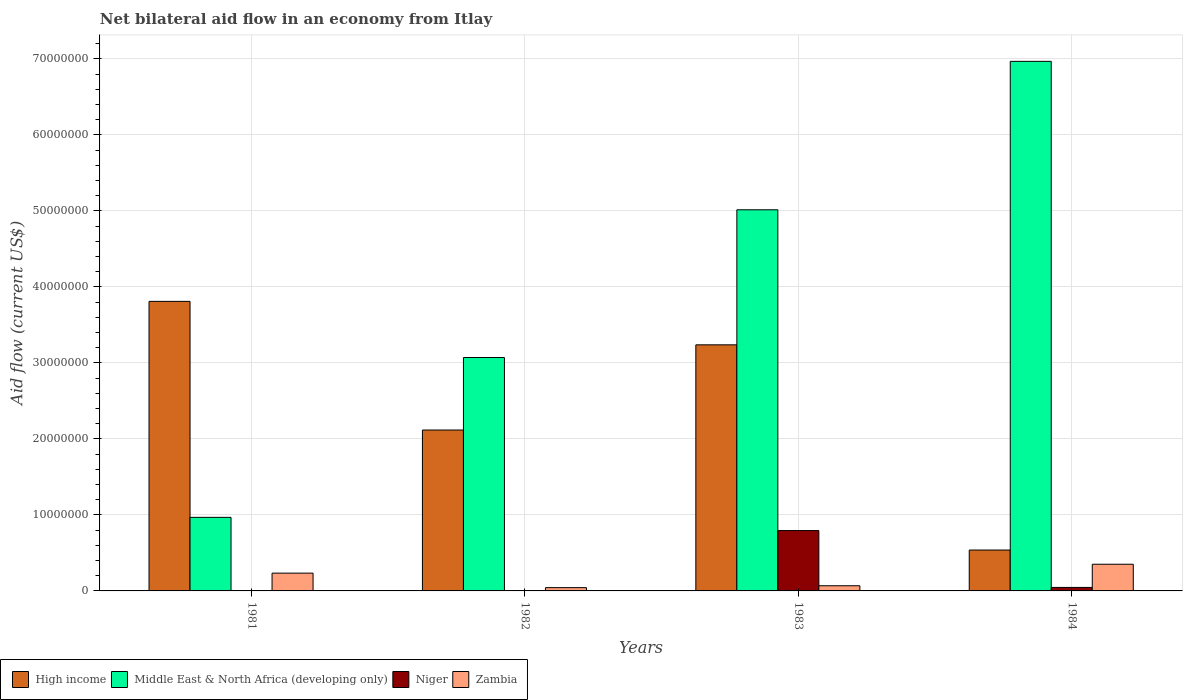How many groups of bars are there?
Offer a very short reply. 4. Are the number of bars per tick equal to the number of legend labels?
Provide a succinct answer. Yes. What is the label of the 3rd group of bars from the left?
Offer a terse response. 1983. In how many cases, is the number of bars for a given year not equal to the number of legend labels?
Offer a very short reply. 0. What is the net bilateral aid flow in Zambia in 1981?
Your answer should be compact. 2.34e+06. Across all years, what is the maximum net bilateral aid flow in Middle East & North Africa (developing only)?
Give a very brief answer. 6.97e+07. What is the total net bilateral aid flow in Middle East & North Africa (developing only) in the graph?
Your response must be concise. 1.60e+08. What is the difference between the net bilateral aid flow in Middle East & North Africa (developing only) in 1983 and that in 1984?
Make the answer very short. -1.95e+07. What is the difference between the net bilateral aid flow in Zambia in 1983 and the net bilateral aid flow in High income in 1984?
Your response must be concise. -4.70e+06. What is the average net bilateral aid flow in High income per year?
Make the answer very short. 2.43e+07. In the year 1981, what is the difference between the net bilateral aid flow in Zambia and net bilateral aid flow in High income?
Provide a succinct answer. -3.58e+07. In how many years, is the net bilateral aid flow in High income greater than 18000000 US$?
Make the answer very short. 3. What is the ratio of the net bilateral aid flow in Zambia in 1981 to that in 1984?
Your answer should be compact. 0.67. Is the net bilateral aid flow in Niger in 1981 less than that in 1982?
Your response must be concise. No. Is the difference between the net bilateral aid flow in Zambia in 1981 and 1984 greater than the difference between the net bilateral aid flow in High income in 1981 and 1984?
Give a very brief answer. No. What is the difference between the highest and the second highest net bilateral aid flow in Middle East & North Africa (developing only)?
Offer a terse response. 1.95e+07. What is the difference between the highest and the lowest net bilateral aid flow in Niger?
Offer a terse response. 7.92e+06. Is it the case that in every year, the sum of the net bilateral aid flow in Middle East & North Africa (developing only) and net bilateral aid flow in Zambia is greater than the sum of net bilateral aid flow in High income and net bilateral aid flow in Niger?
Provide a succinct answer. No. What does the 2nd bar from the left in 1984 represents?
Your answer should be very brief. Middle East & North Africa (developing only). What does the 2nd bar from the right in 1981 represents?
Give a very brief answer. Niger. Are all the bars in the graph horizontal?
Offer a very short reply. No. Does the graph contain any zero values?
Ensure brevity in your answer.  No. Where does the legend appear in the graph?
Provide a short and direct response. Bottom left. What is the title of the graph?
Make the answer very short. Net bilateral aid flow in an economy from Itlay. Does "Jamaica" appear as one of the legend labels in the graph?
Ensure brevity in your answer.  No. What is the label or title of the X-axis?
Keep it short and to the point. Years. What is the label or title of the Y-axis?
Make the answer very short. Aid flow (current US$). What is the Aid flow (current US$) of High income in 1981?
Offer a terse response. 3.81e+07. What is the Aid flow (current US$) of Middle East & North Africa (developing only) in 1981?
Make the answer very short. 9.68e+06. What is the Aid flow (current US$) in Niger in 1981?
Your response must be concise. 4.00e+04. What is the Aid flow (current US$) in Zambia in 1981?
Offer a very short reply. 2.34e+06. What is the Aid flow (current US$) of High income in 1982?
Give a very brief answer. 2.12e+07. What is the Aid flow (current US$) of Middle East & North Africa (developing only) in 1982?
Offer a terse response. 3.07e+07. What is the Aid flow (current US$) in Zambia in 1982?
Ensure brevity in your answer.  4.30e+05. What is the Aid flow (current US$) of High income in 1983?
Provide a succinct answer. 3.24e+07. What is the Aid flow (current US$) in Middle East & North Africa (developing only) in 1983?
Keep it short and to the point. 5.02e+07. What is the Aid flow (current US$) in Niger in 1983?
Your answer should be very brief. 7.94e+06. What is the Aid flow (current US$) of Zambia in 1983?
Your response must be concise. 6.80e+05. What is the Aid flow (current US$) in High income in 1984?
Keep it short and to the point. 5.38e+06. What is the Aid flow (current US$) of Middle East & North Africa (developing only) in 1984?
Provide a short and direct response. 6.97e+07. What is the Aid flow (current US$) in Zambia in 1984?
Your response must be concise. 3.51e+06. Across all years, what is the maximum Aid flow (current US$) of High income?
Give a very brief answer. 3.81e+07. Across all years, what is the maximum Aid flow (current US$) of Middle East & North Africa (developing only)?
Your response must be concise. 6.97e+07. Across all years, what is the maximum Aid flow (current US$) of Niger?
Offer a terse response. 7.94e+06. Across all years, what is the maximum Aid flow (current US$) in Zambia?
Your response must be concise. 3.51e+06. Across all years, what is the minimum Aid flow (current US$) of High income?
Offer a very short reply. 5.38e+06. Across all years, what is the minimum Aid flow (current US$) in Middle East & North Africa (developing only)?
Offer a very short reply. 9.68e+06. Across all years, what is the minimum Aid flow (current US$) in Niger?
Your answer should be very brief. 2.00e+04. What is the total Aid flow (current US$) in High income in the graph?
Give a very brief answer. 9.70e+07. What is the total Aid flow (current US$) of Middle East & North Africa (developing only) in the graph?
Your answer should be compact. 1.60e+08. What is the total Aid flow (current US$) in Niger in the graph?
Keep it short and to the point. 8.46e+06. What is the total Aid flow (current US$) of Zambia in the graph?
Give a very brief answer. 6.96e+06. What is the difference between the Aid flow (current US$) in High income in 1981 and that in 1982?
Your answer should be compact. 1.69e+07. What is the difference between the Aid flow (current US$) in Middle East & North Africa (developing only) in 1981 and that in 1982?
Make the answer very short. -2.10e+07. What is the difference between the Aid flow (current US$) in Niger in 1981 and that in 1982?
Your response must be concise. 2.00e+04. What is the difference between the Aid flow (current US$) of Zambia in 1981 and that in 1982?
Your answer should be compact. 1.91e+06. What is the difference between the Aid flow (current US$) of High income in 1981 and that in 1983?
Keep it short and to the point. 5.72e+06. What is the difference between the Aid flow (current US$) of Middle East & North Africa (developing only) in 1981 and that in 1983?
Give a very brief answer. -4.05e+07. What is the difference between the Aid flow (current US$) in Niger in 1981 and that in 1983?
Your response must be concise. -7.90e+06. What is the difference between the Aid flow (current US$) in Zambia in 1981 and that in 1983?
Keep it short and to the point. 1.66e+06. What is the difference between the Aid flow (current US$) in High income in 1981 and that in 1984?
Offer a terse response. 3.27e+07. What is the difference between the Aid flow (current US$) in Middle East & North Africa (developing only) in 1981 and that in 1984?
Provide a succinct answer. -6.00e+07. What is the difference between the Aid flow (current US$) of Niger in 1981 and that in 1984?
Your answer should be very brief. -4.20e+05. What is the difference between the Aid flow (current US$) in Zambia in 1981 and that in 1984?
Provide a short and direct response. -1.17e+06. What is the difference between the Aid flow (current US$) of High income in 1982 and that in 1983?
Provide a succinct answer. -1.12e+07. What is the difference between the Aid flow (current US$) of Middle East & North Africa (developing only) in 1982 and that in 1983?
Ensure brevity in your answer.  -1.94e+07. What is the difference between the Aid flow (current US$) of Niger in 1982 and that in 1983?
Offer a very short reply. -7.92e+06. What is the difference between the Aid flow (current US$) in High income in 1982 and that in 1984?
Make the answer very short. 1.58e+07. What is the difference between the Aid flow (current US$) of Middle East & North Africa (developing only) in 1982 and that in 1984?
Give a very brief answer. -3.90e+07. What is the difference between the Aid flow (current US$) of Niger in 1982 and that in 1984?
Your answer should be very brief. -4.40e+05. What is the difference between the Aid flow (current US$) of Zambia in 1982 and that in 1984?
Offer a very short reply. -3.08e+06. What is the difference between the Aid flow (current US$) in High income in 1983 and that in 1984?
Provide a succinct answer. 2.70e+07. What is the difference between the Aid flow (current US$) of Middle East & North Africa (developing only) in 1983 and that in 1984?
Keep it short and to the point. -1.95e+07. What is the difference between the Aid flow (current US$) of Niger in 1983 and that in 1984?
Offer a terse response. 7.48e+06. What is the difference between the Aid flow (current US$) of Zambia in 1983 and that in 1984?
Make the answer very short. -2.83e+06. What is the difference between the Aid flow (current US$) in High income in 1981 and the Aid flow (current US$) in Middle East & North Africa (developing only) in 1982?
Keep it short and to the point. 7.39e+06. What is the difference between the Aid flow (current US$) of High income in 1981 and the Aid flow (current US$) of Niger in 1982?
Offer a terse response. 3.81e+07. What is the difference between the Aid flow (current US$) of High income in 1981 and the Aid flow (current US$) of Zambia in 1982?
Offer a very short reply. 3.77e+07. What is the difference between the Aid flow (current US$) in Middle East & North Africa (developing only) in 1981 and the Aid flow (current US$) in Niger in 1982?
Provide a succinct answer. 9.66e+06. What is the difference between the Aid flow (current US$) in Middle East & North Africa (developing only) in 1981 and the Aid flow (current US$) in Zambia in 1982?
Ensure brevity in your answer.  9.25e+06. What is the difference between the Aid flow (current US$) in Niger in 1981 and the Aid flow (current US$) in Zambia in 1982?
Give a very brief answer. -3.90e+05. What is the difference between the Aid flow (current US$) of High income in 1981 and the Aid flow (current US$) of Middle East & North Africa (developing only) in 1983?
Your answer should be very brief. -1.20e+07. What is the difference between the Aid flow (current US$) in High income in 1981 and the Aid flow (current US$) in Niger in 1983?
Your answer should be very brief. 3.02e+07. What is the difference between the Aid flow (current US$) in High income in 1981 and the Aid flow (current US$) in Zambia in 1983?
Give a very brief answer. 3.74e+07. What is the difference between the Aid flow (current US$) in Middle East & North Africa (developing only) in 1981 and the Aid flow (current US$) in Niger in 1983?
Keep it short and to the point. 1.74e+06. What is the difference between the Aid flow (current US$) in Middle East & North Africa (developing only) in 1981 and the Aid flow (current US$) in Zambia in 1983?
Offer a very short reply. 9.00e+06. What is the difference between the Aid flow (current US$) of Niger in 1981 and the Aid flow (current US$) of Zambia in 1983?
Ensure brevity in your answer.  -6.40e+05. What is the difference between the Aid flow (current US$) in High income in 1981 and the Aid flow (current US$) in Middle East & North Africa (developing only) in 1984?
Your answer should be compact. -3.16e+07. What is the difference between the Aid flow (current US$) in High income in 1981 and the Aid flow (current US$) in Niger in 1984?
Your answer should be compact. 3.76e+07. What is the difference between the Aid flow (current US$) in High income in 1981 and the Aid flow (current US$) in Zambia in 1984?
Offer a very short reply. 3.46e+07. What is the difference between the Aid flow (current US$) in Middle East & North Africa (developing only) in 1981 and the Aid flow (current US$) in Niger in 1984?
Your response must be concise. 9.22e+06. What is the difference between the Aid flow (current US$) in Middle East & North Africa (developing only) in 1981 and the Aid flow (current US$) in Zambia in 1984?
Your response must be concise. 6.17e+06. What is the difference between the Aid flow (current US$) in Niger in 1981 and the Aid flow (current US$) in Zambia in 1984?
Ensure brevity in your answer.  -3.47e+06. What is the difference between the Aid flow (current US$) of High income in 1982 and the Aid flow (current US$) of Middle East & North Africa (developing only) in 1983?
Ensure brevity in your answer.  -2.90e+07. What is the difference between the Aid flow (current US$) in High income in 1982 and the Aid flow (current US$) in Niger in 1983?
Provide a succinct answer. 1.32e+07. What is the difference between the Aid flow (current US$) of High income in 1982 and the Aid flow (current US$) of Zambia in 1983?
Offer a very short reply. 2.05e+07. What is the difference between the Aid flow (current US$) in Middle East & North Africa (developing only) in 1982 and the Aid flow (current US$) in Niger in 1983?
Your answer should be compact. 2.28e+07. What is the difference between the Aid flow (current US$) in Middle East & North Africa (developing only) in 1982 and the Aid flow (current US$) in Zambia in 1983?
Give a very brief answer. 3.00e+07. What is the difference between the Aid flow (current US$) in Niger in 1982 and the Aid flow (current US$) in Zambia in 1983?
Your response must be concise. -6.60e+05. What is the difference between the Aid flow (current US$) of High income in 1982 and the Aid flow (current US$) of Middle East & North Africa (developing only) in 1984?
Provide a succinct answer. -4.85e+07. What is the difference between the Aid flow (current US$) of High income in 1982 and the Aid flow (current US$) of Niger in 1984?
Offer a terse response. 2.07e+07. What is the difference between the Aid flow (current US$) in High income in 1982 and the Aid flow (current US$) in Zambia in 1984?
Make the answer very short. 1.77e+07. What is the difference between the Aid flow (current US$) in Middle East & North Africa (developing only) in 1982 and the Aid flow (current US$) in Niger in 1984?
Offer a terse response. 3.02e+07. What is the difference between the Aid flow (current US$) in Middle East & North Africa (developing only) in 1982 and the Aid flow (current US$) in Zambia in 1984?
Your answer should be compact. 2.72e+07. What is the difference between the Aid flow (current US$) in Niger in 1982 and the Aid flow (current US$) in Zambia in 1984?
Make the answer very short. -3.49e+06. What is the difference between the Aid flow (current US$) in High income in 1983 and the Aid flow (current US$) in Middle East & North Africa (developing only) in 1984?
Offer a very short reply. -3.73e+07. What is the difference between the Aid flow (current US$) of High income in 1983 and the Aid flow (current US$) of Niger in 1984?
Make the answer very short. 3.19e+07. What is the difference between the Aid flow (current US$) of High income in 1983 and the Aid flow (current US$) of Zambia in 1984?
Offer a terse response. 2.89e+07. What is the difference between the Aid flow (current US$) in Middle East & North Africa (developing only) in 1983 and the Aid flow (current US$) in Niger in 1984?
Ensure brevity in your answer.  4.97e+07. What is the difference between the Aid flow (current US$) in Middle East & North Africa (developing only) in 1983 and the Aid flow (current US$) in Zambia in 1984?
Provide a succinct answer. 4.66e+07. What is the difference between the Aid flow (current US$) of Niger in 1983 and the Aid flow (current US$) of Zambia in 1984?
Your response must be concise. 4.43e+06. What is the average Aid flow (current US$) of High income per year?
Your answer should be very brief. 2.43e+07. What is the average Aid flow (current US$) in Middle East & North Africa (developing only) per year?
Make the answer very short. 4.01e+07. What is the average Aid flow (current US$) of Niger per year?
Keep it short and to the point. 2.12e+06. What is the average Aid flow (current US$) in Zambia per year?
Your response must be concise. 1.74e+06. In the year 1981, what is the difference between the Aid flow (current US$) in High income and Aid flow (current US$) in Middle East & North Africa (developing only)?
Give a very brief answer. 2.84e+07. In the year 1981, what is the difference between the Aid flow (current US$) of High income and Aid flow (current US$) of Niger?
Ensure brevity in your answer.  3.81e+07. In the year 1981, what is the difference between the Aid flow (current US$) of High income and Aid flow (current US$) of Zambia?
Provide a succinct answer. 3.58e+07. In the year 1981, what is the difference between the Aid flow (current US$) in Middle East & North Africa (developing only) and Aid flow (current US$) in Niger?
Offer a terse response. 9.64e+06. In the year 1981, what is the difference between the Aid flow (current US$) of Middle East & North Africa (developing only) and Aid flow (current US$) of Zambia?
Offer a terse response. 7.34e+06. In the year 1981, what is the difference between the Aid flow (current US$) in Niger and Aid flow (current US$) in Zambia?
Offer a terse response. -2.30e+06. In the year 1982, what is the difference between the Aid flow (current US$) in High income and Aid flow (current US$) in Middle East & North Africa (developing only)?
Provide a succinct answer. -9.54e+06. In the year 1982, what is the difference between the Aid flow (current US$) of High income and Aid flow (current US$) of Niger?
Provide a short and direct response. 2.12e+07. In the year 1982, what is the difference between the Aid flow (current US$) of High income and Aid flow (current US$) of Zambia?
Provide a short and direct response. 2.07e+07. In the year 1982, what is the difference between the Aid flow (current US$) in Middle East & North Africa (developing only) and Aid flow (current US$) in Niger?
Offer a terse response. 3.07e+07. In the year 1982, what is the difference between the Aid flow (current US$) of Middle East & North Africa (developing only) and Aid flow (current US$) of Zambia?
Your response must be concise. 3.03e+07. In the year 1982, what is the difference between the Aid flow (current US$) in Niger and Aid flow (current US$) in Zambia?
Your answer should be compact. -4.10e+05. In the year 1983, what is the difference between the Aid flow (current US$) of High income and Aid flow (current US$) of Middle East & North Africa (developing only)?
Provide a short and direct response. -1.78e+07. In the year 1983, what is the difference between the Aid flow (current US$) of High income and Aid flow (current US$) of Niger?
Ensure brevity in your answer.  2.44e+07. In the year 1983, what is the difference between the Aid flow (current US$) of High income and Aid flow (current US$) of Zambia?
Make the answer very short. 3.17e+07. In the year 1983, what is the difference between the Aid flow (current US$) of Middle East & North Africa (developing only) and Aid flow (current US$) of Niger?
Your answer should be compact. 4.22e+07. In the year 1983, what is the difference between the Aid flow (current US$) in Middle East & North Africa (developing only) and Aid flow (current US$) in Zambia?
Give a very brief answer. 4.95e+07. In the year 1983, what is the difference between the Aid flow (current US$) in Niger and Aid flow (current US$) in Zambia?
Your answer should be very brief. 7.26e+06. In the year 1984, what is the difference between the Aid flow (current US$) in High income and Aid flow (current US$) in Middle East & North Africa (developing only)?
Give a very brief answer. -6.43e+07. In the year 1984, what is the difference between the Aid flow (current US$) in High income and Aid flow (current US$) in Niger?
Ensure brevity in your answer.  4.92e+06. In the year 1984, what is the difference between the Aid flow (current US$) of High income and Aid flow (current US$) of Zambia?
Your answer should be compact. 1.87e+06. In the year 1984, what is the difference between the Aid flow (current US$) in Middle East & North Africa (developing only) and Aid flow (current US$) in Niger?
Provide a short and direct response. 6.92e+07. In the year 1984, what is the difference between the Aid flow (current US$) in Middle East & North Africa (developing only) and Aid flow (current US$) in Zambia?
Provide a succinct answer. 6.62e+07. In the year 1984, what is the difference between the Aid flow (current US$) in Niger and Aid flow (current US$) in Zambia?
Ensure brevity in your answer.  -3.05e+06. What is the ratio of the Aid flow (current US$) of High income in 1981 to that in 1982?
Provide a succinct answer. 1.8. What is the ratio of the Aid flow (current US$) of Middle East & North Africa (developing only) in 1981 to that in 1982?
Offer a very short reply. 0.32. What is the ratio of the Aid flow (current US$) of Zambia in 1981 to that in 1982?
Provide a short and direct response. 5.44. What is the ratio of the Aid flow (current US$) in High income in 1981 to that in 1983?
Ensure brevity in your answer.  1.18. What is the ratio of the Aid flow (current US$) in Middle East & North Africa (developing only) in 1981 to that in 1983?
Your answer should be very brief. 0.19. What is the ratio of the Aid flow (current US$) of Niger in 1981 to that in 1983?
Offer a very short reply. 0.01. What is the ratio of the Aid flow (current US$) of Zambia in 1981 to that in 1983?
Your answer should be very brief. 3.44. What is the ratio of the Aid flow (current US$) in High income in 1981 to that in 1984?
Offer a very short reply. 7.08. What is the ratio of the Aid flow (current US$) of Middle East & North Africa (developing only) in 1981 to that in 1984?
Offer a very short reply. 0.14. What is the ratio of the Aid flow (current US$) of Niger in 1981 to that in 1984?
Offer a very short reply. 0.09. What is the ratio of the Aid flow (current US$) in Zambia in 1981 to that in 1984?
Give a very brief answer. 0.67. What is the ratio of the Aid flow (current US$) of High income in 1982 to that in 1983?
Offer a very short reply. 0.65. What is the ratio of the Aid flow (current US$) in Middle East & North Africa (developing only) in 1982 to that in 1983?
Provide a succinct answer. 0.61. What is the ratio of the Aid flow (current US$) of Niger in 1982 to that in 1983?
Provide a succinct answer. 0. What is the ratio of the Aid flow (current US$) of Zambia in 1982 to that in 1983?
Ensure brevity in your answer.  0.63. What is the ratio of the Aid flow (current US$) in High income in 1982 to that in 1984?
Your answer should be compact. 3.93. What is the ratio of the Aid flow (current US$) of Middle East & North Africa (developing only) in 1982 to that in 1984?
Provide a short and direct response. 0.44. What is the ratio of the Aid flow (current US$) of Niger in 1982 to that in 1984?
Your response must be concise. 0.04. What is the ratio of the Aid flow (current US$) in Zambia in 1982 to that in 1984?
Your answer should be very brief. 0.12. What is the ratio of the Aid flow (current US$) of High income in 1983 to that in 1984?
Offer a terse response. 6.02. What is the ratio of the Aid flow (current US$) in Middle East & North Africa (developing only) in 1983 to that in 1984?
Your answer should be very brief. 0.72. What is the ratio of the Aid flow (current US$) in Niger in 1983 to that in 1984?
Provide a short and direct response. 17.26. What is the ratio of the Aid flow (current US$) of Zambia in 1983 to that in 1984?
Make the answer very short. 0.19. What is the difference between the highest and the second highest Aid flow (current US$) of High income?
Provide a succinct answer. 5.72e+06. What is the difference between the highest and the second highest Aid flow (current US$) in Middle East & North Africa (developing only)?
Keep it short and to the point. 1.95e+07. What is the difference between the highest and the second highest Aid flow (current US$) in Niger?
Keep it short and to the point. 7.48e+06. What is the difference between the highest and the second highest Aid flow (current US$) of Zambia?
Ensure brevity in your answer.  1.17e+06. What is the difference between the highest and the lowest Aid flow (current US$) in High income?
Ensure brevity in your answer.  3.27e+07. What is the difference between the highest and the lowest Aid flow (current US$) of Middle East & North Africa (developing only)?
Keep it short and to the point. 6.00e+07. What is the difference between the highest and the lowest Aid flow (current US$) of Niger?
Offer a terse response. 7.92e+06. What is the difference between the highest and the lowest Aid flow (current US$) of Zambia?
Make the answer very short. 3.08e+06. 